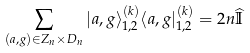Convert formula to latex. <formula><loc_0><loc_0><loc_500><loc_500>\sum _ { ( a , g ) \in Z _ { n } \times D _ { n } } | a , g \rangle ^ { ( k ) } _ { 1 , 2 } \langle a , g | ^ { ( k ) } _ { 1 , 2 } = 2 n \widehat { \mathbb { I } }</formula> 